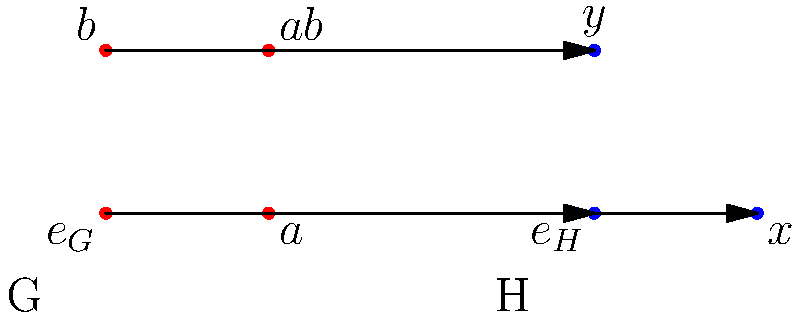As a UX designer, you're tasked with creating a visual representation of a group homomorphism between two groups G and H. The diagram shows a potential mapping. Which property of group homomorphisms is violated by this visual representation, and how would you suggest modifying the diagram to correct it? To answer this question, let's analyze the properties of group homomorphisms and how they relate to the given diagram:

1. A group homomorphism $\phi: G \rightarrow H$ must preserve the group operation. That is, for all $a, b \in G$, $\phi(ab) = \phi(a)\phi(b)$.

2. In the diagram, we can identify the following mappings:
   - $\phi(e_G) = e_H$
   - $\phi(a) = x$
   - $\phi(b) = y$
   - $\phi(ab) = y$

3. To check if the homomorphism property is satisfied, we need to verify:
   $\phi(ab) \stackrel{?}{=} \phi(a)\phi(b)$

4. From the diagram:
   $\phi(ab) = y$
   $\phi(a)\phi(b) = xy$

5. Since $y \neq xy$ in general, this mapping violates the homomorphism property.

6. To correct the diagram, we need to ensure that $\phi(ab) = \phi(a)\phi(b) = xy$.

7. As a UX designer, you could suggest the following modifications:
   - Add a fourth element to group H representing $xy$.
   - Change the arrow from $ab$ in G to point to this new element in H.
   - Use color coding or different arrow styles to distinguish between direct mappings and derived mappings (e.g., $xy$ as a result of $\phi(a)\phi(b)$).

8. These changes would make the visual representation more accurate and intuitive, improving the user's understanding of group homomorphisms.
Answer: The homomorphism property $\phi(ab) = \phi(a)\phi(b)$ is violated; add element $xy$ to H and redirect $\phi(ab)$ to it. 